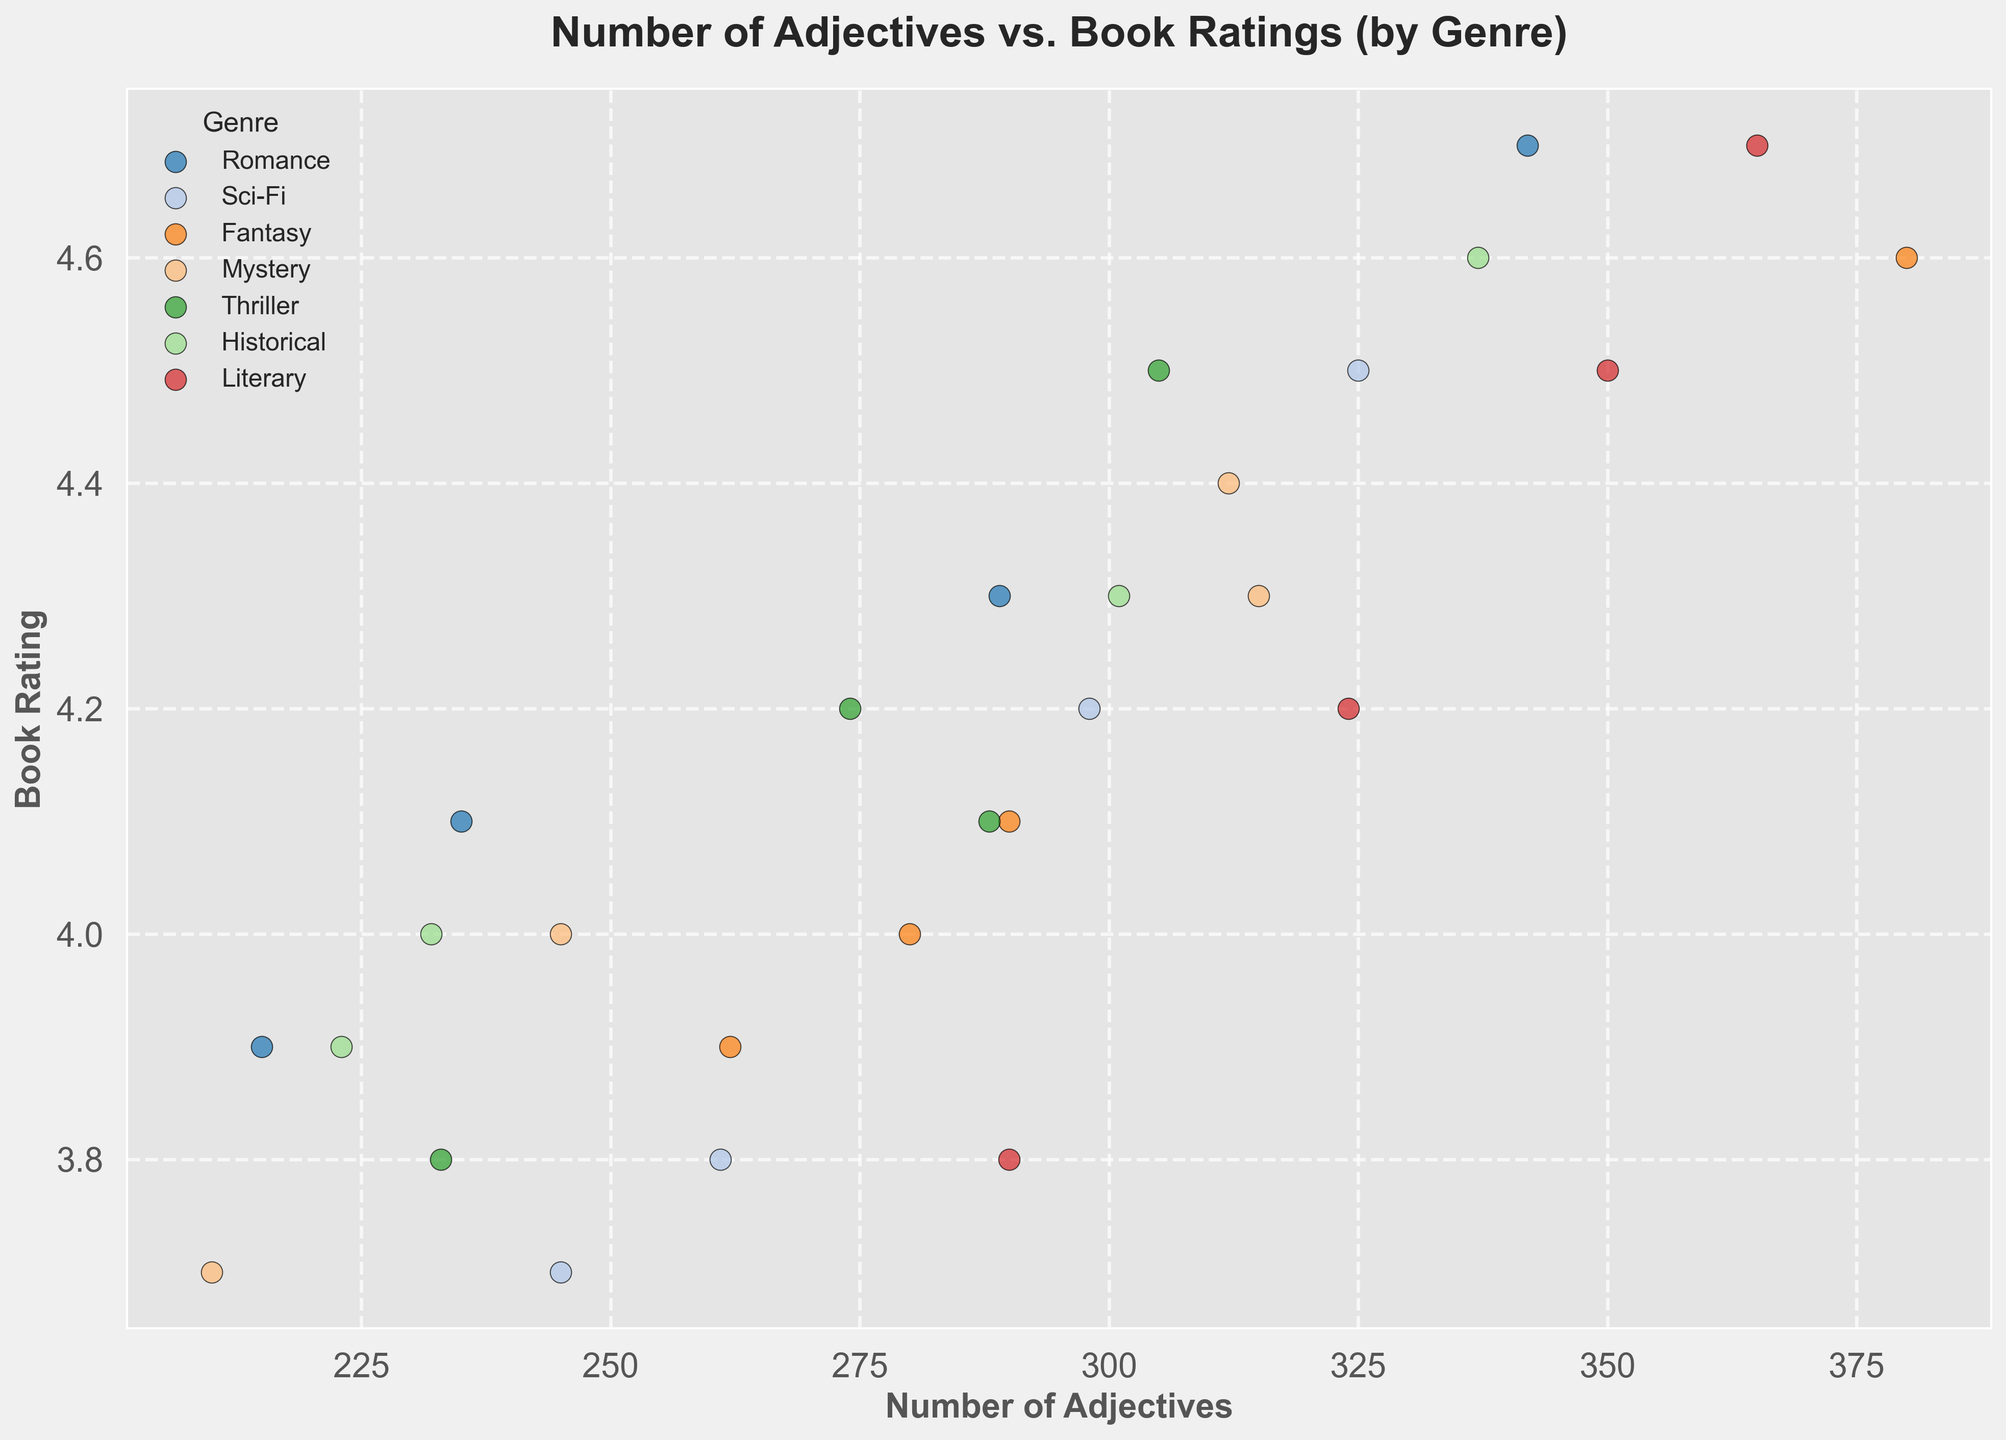How does the number of adjectives in Romance novels compare to the number of adjectives in Mystery novels? By examining the scatter plot, we can observe the number of adjectives for each genre. For Romance novels, the number of adjectives ranges from 215 to 342. For Mystery novels, the number ranges from 210 to 315. We compare these ranges to find that Romance novels generally have more adjectives than Mystery novels.
Answer: Romance novels generally have more adjectives than Mystery novels Which genre has the highest book rating for novels with more than 300 adjectives? We need to locate the point for each genre where the number of adjectives is more than 300 and find the highest rating among these points. By looking at the scatter plot, we find that the highest rating with more than 300 adjectives is for Literary novels with a rating of 4.7.
Answer: Literary Is there a genre where books with fewer adjectives receive higher ratings than books with more adjectives? Examining the scatter plot for each genre individually, we notice that in Historical novels, the book with 223 adjectives has a rating of 3.9, while the book with 301 adjectives has a rating of 4.3. For all genres, it trends towards higher ratings with more adjectives. Therefore, no such genre exists.
Answer: No Which genre shows the most variation in book ratings? We look at the vertical spread of the points for each genre to measure the variation. Romance and Literary genres show the widest spread in ratings from 3.8 to 4.7, indicating the most variation.
Answer: Romance and Literary What is the average number of adjectives used in Fantasy novels? To find the average, sum the number of adjectives used in Fantasy novels (380 + 290 + 262 + 280) and divide by the number of data points (4). The sum is 1212, so the average is 1212 ÷ 4 = 303.
Answer: 303 Are there any genres where the book ratings are all above 4.0? Looking at the scatter plot, we identify the book ratings for each genre: Romance, Sci-Fi, Fantasy, Literary, and Thriller have ratings above 4.0 for all books in those genres.
Answer: Romance, Sci-Fi, Fantasy, Literary, and Thriller Do Sci-Fi novels with more adjectives tend to have higher ratings than those with fewer adjectives? We compare the points for Sci-Fi novels, observing that the number of adjectives ranges from 245 to 325 and the ratings from 3.7 to 4.5. Higher-rated books (>4.2) generally have more adjectives (>298).
Answer: Yes Which genre's novels with the least number of adjectives still receive a high rating above 4.0? Identify the lowest adjective count for each genre and the corresponding rating. For Mystery, the lowest count with the highest rating is 210 with a rating of 4.0.
Answer: Mystery 